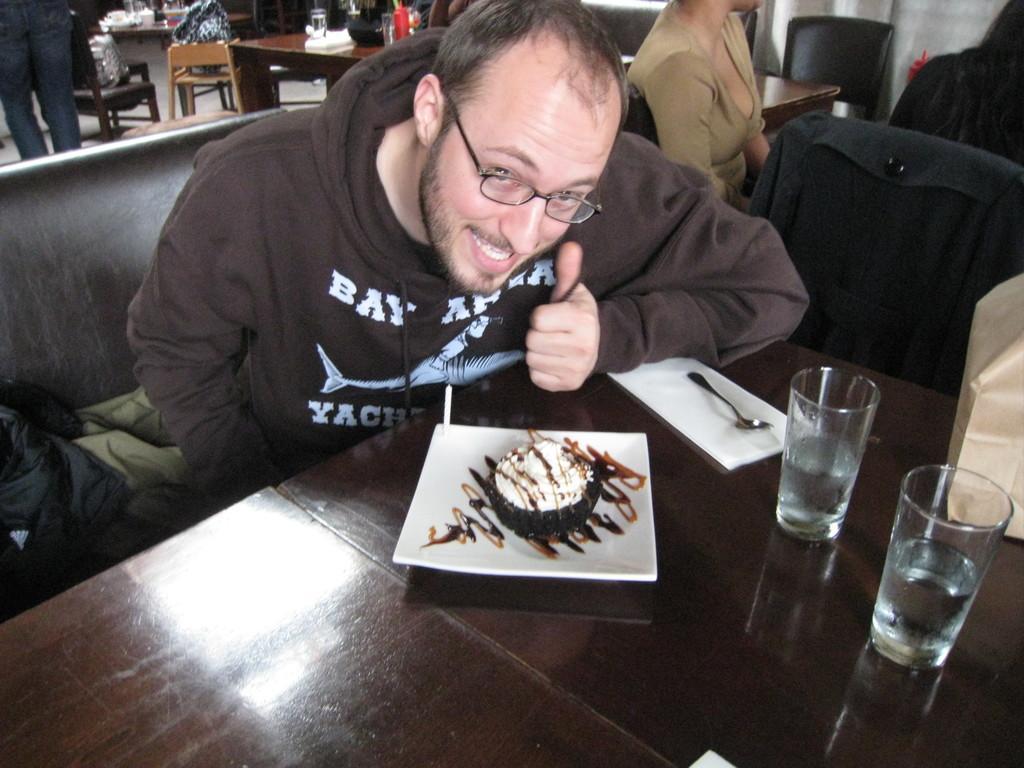In one or two sentences, can you explain what this image depicts? Here is the man sitting on the couch. This is the table with glasses,paper,spoon,plate placed on the table. This looks like a desert on the plate. There are two women sitting on the chairs. At background i can see another table with few things on it. This is a chair. Here is the another person standing. This looks like a bag placed on the chair. Here I can see a brown color object at the right corner of the image is placed on the table. 